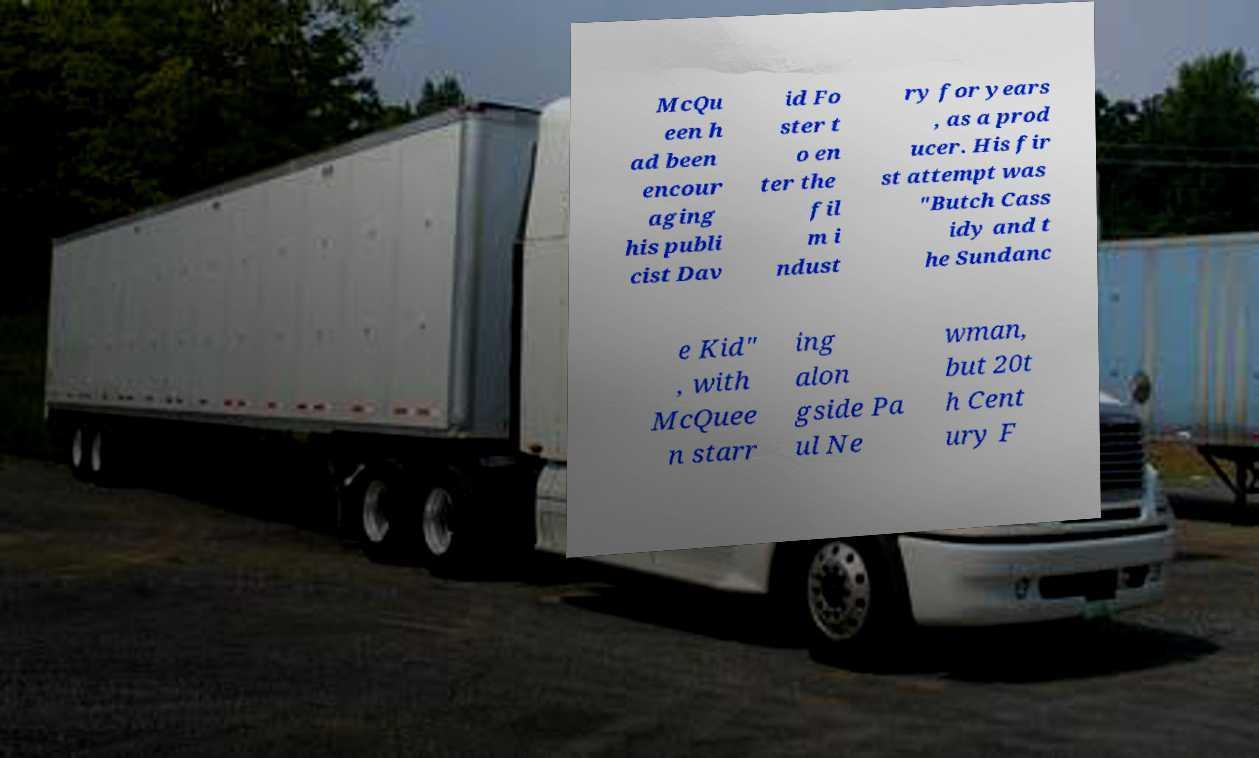Please identify and transcribe the text found in this image. McQu een h ad been encour aging his publi cist Dav id Fo ster t o en ter the fil m i ndust ry for years , as a prod ucer. His fir st attempt was "Butch Cass idy and t he Sundanc e Kid" , with McQuee n starr ing alon gside Pa ul Ne wman, but 20t h Cent ury F 